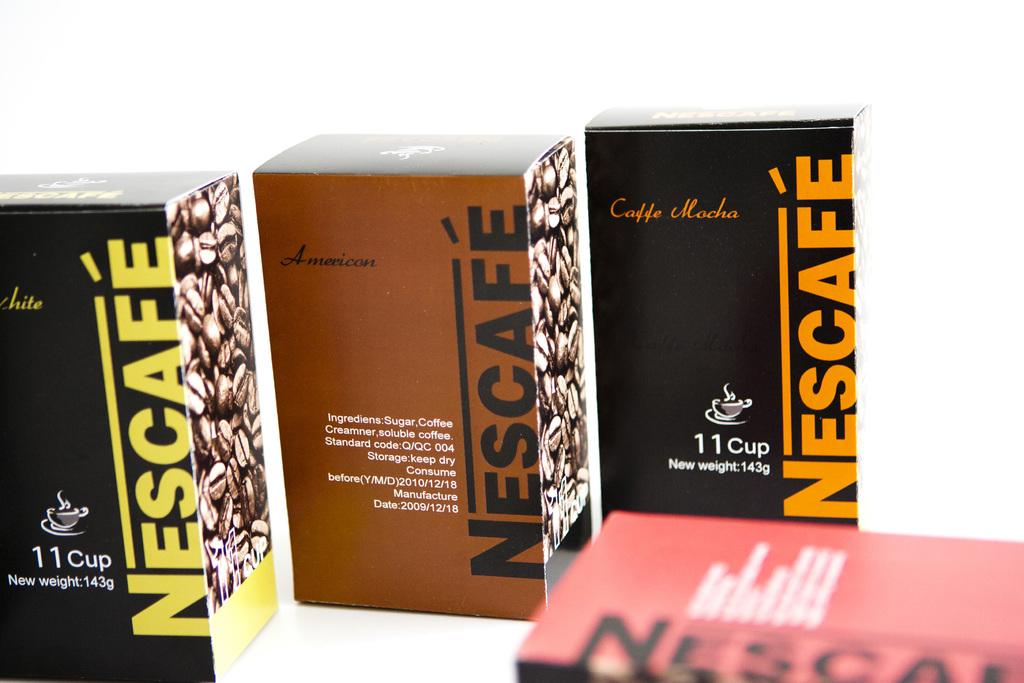<image>
Offer a succinct explanation of the picture presented. Three boxes of Nescafe right next to one another with the middle one being brown. 